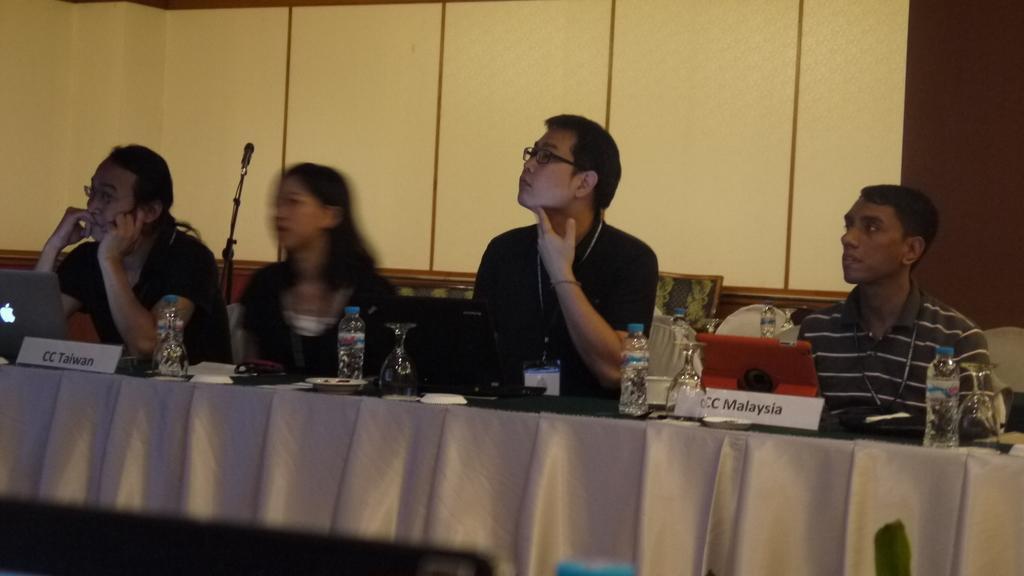How would you summarize this image in a sentence or two? In the image there are few people sat on chair in front of table with mic ,laptop and with water bottle on it,this looks like a meeting room. 